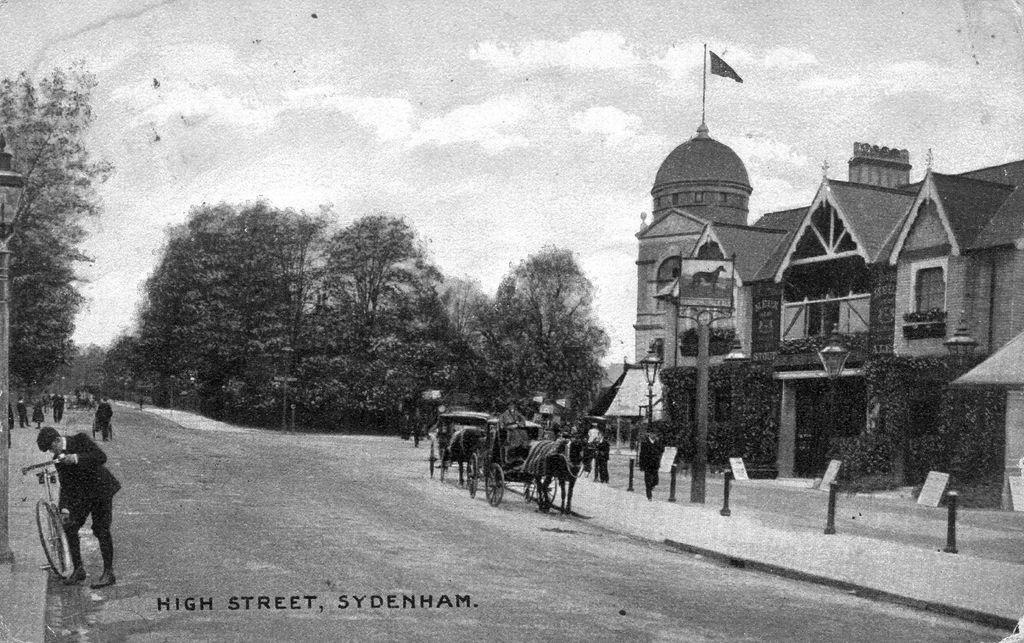What type of vehicles can be seen in the image? There are bull carts in the image. What are the people in the image doing? The people in the image are walking on the road. What structure is visible in the image? There is a building visible in the image. What type of vegetation is present in the image? There are trees present in the image. Can you see a nest in the image? There is no nest present in the image. How many people are coughing in the image? There is no indication of anyone coughing in the image. 